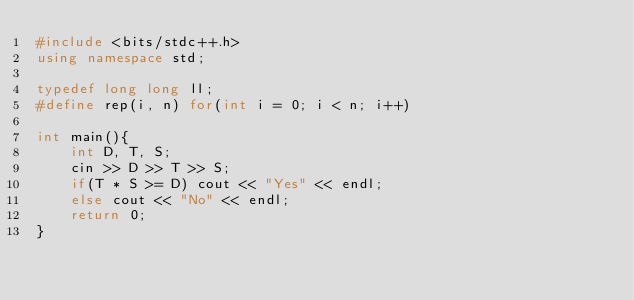<code> <loc_0><loc_0><loc_500><loc_500><_C++_>#include <bits/stdc++.h>
using namespace std;

typedef long long ll;
#define rep(i, n) for(int i = 0; i < n; i++)

int main(){
    int D, T, S;
    cin >> D >> T >> S;
    if(T * S >= D) cout << "Yes" << endl;
    else cout << "No" << endl;
    return 0;
}</code> 